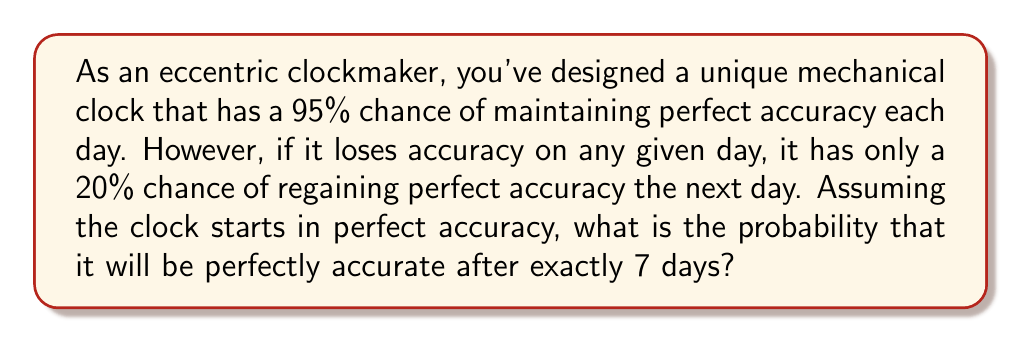Give your solution to this math problem. To solve this problem, we can use a discrete-time Markov chain with two states: Accurate (A) and Inaccurate (I). Let's break down the solution step-by-step:

1) First, we need to define our transition matrix P:

   $$P = \begin{bmatrix}
   0.95 & 0.05 \\
   0.20 & 0.80
   \end{bmatrix}$$

   Where $P_{ij}$ is the probability of transitioning from state i to state j.

2) We want to find the probability of being in state A after 7 transitions, given that we start in state A. This can be calculated by raising P to the 7th power and looking at the element in the first row, first column.

3) To calculate $P^7$, we can use eigendecomposition:
   
   $$P = QDQ^{-1}$$
   
   Where D is a diagonal matrix of eigenvalues and Q is a matrix of eigenvectors.

4) The eigenvalues of P are:
   
   $$\lambda_1 = 1, \lambda_2 = 0.75$$

5) The corresponding eigenvectors are:

   $$v_1 = \begin{bmatrix} 0.8 \\ 0.2 \end{bmatrix}, v_2 = \begin{bmatrix} 1 \\ -1 \end{bmatrix}$$

6) Now we can form Q and D:

   $$Q = \begin{bmatrix} 0.8 & 1 \\ 0.2 & -1 \end{bmatrix}, 
     D = \begin{bmatrix} 1 & 0 \\ 0 & 0.75 \end{bmatrix}$$

7) Calculate $Q^{-1}$:

   $$Q^{-1} = \begin{bmatrix} 0.5 & 0.5 \\ 0.1 & -0.1 \end{bmatrix}$$

8) Now we can calculate $P^7$:

   $$P^7 = QD^7Q^{-1} = \begin{bmatrix} 0.8 & 1 \\ 0.2 & -1 \end{bmatrix}
   \begin{bmatrix} 1 & 0 \\ 0 & 0.75^7 \end{bmatrix}
   \begin{bmatrix} 0.5 & 0.5 \\ 0.1 & -0.1 \end{bmatrix}$$

9) Performing the matrix multiplication:

   $$P^7 = \begin{bmatrix} 
   0.8 + 0.2 \cdot 0.75^7 & 0.2 - 0.2 \cdot 0.75^7 \\
   0.2 - 0.2 \cdot 0.75^7 & 0.8 + 0.2 \cdot 0.75^7
   \end{bmatrix}$$

10) The probability we're looking for is the element in the first row, first column:

    $$P(A \text{ after 7 days}) = 0.8 + 0.2 \cdot 0.75^7 \approx 0.8132$$
Answer: The probability that the clock will be perfectly accurate after exactly 7 days is approximately 0.8132 or 81.32%. 